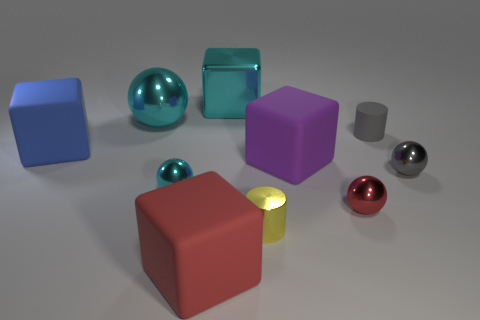Is the color of the small shiny thing that is to the right of the red metal sphere the same as the tiny matte cylinder?
Provide a succinct answer. Yes. Does the large thing in front of the big purple matte object have the same color as the shiny sphere in front of the small cyan shiny sphere?
Your answer should be very brief. Yes. The red object that is to the left of the cylinder to the left of the large purple thing is made of what material?
Provide a short and direct response. Rubber. There is a sphere that is the same size as the blue cube; what color is it?
Ensure brevity in your answer.  Cyan. Do the blue thing and the red object that is to the left of the tiny red metallic thing have the same shape?
Offer a terse response. Yes. There is a large object that is the same color as the big metal sphere; what is its shape?
Offer a terse response. Cube. There is a big thing in front of the cyan ball in front of the gray cylinder; how many big cyan blocks are to the right of it?
Make the answer very short. 1. There is a red object behind the big cube that is in front of the small yellow metal thing; what is its size?
Ensure brevity in your answer.  Small. There is a gray sphere that is made of the same material as the tiny red ball; what size is it?
Your answer should be compact. Small. There is a rubber object that is behind the large purple cube and right of the small cyan object; what shape is it?
Ensure brevity in your answer.  Cylinder. 